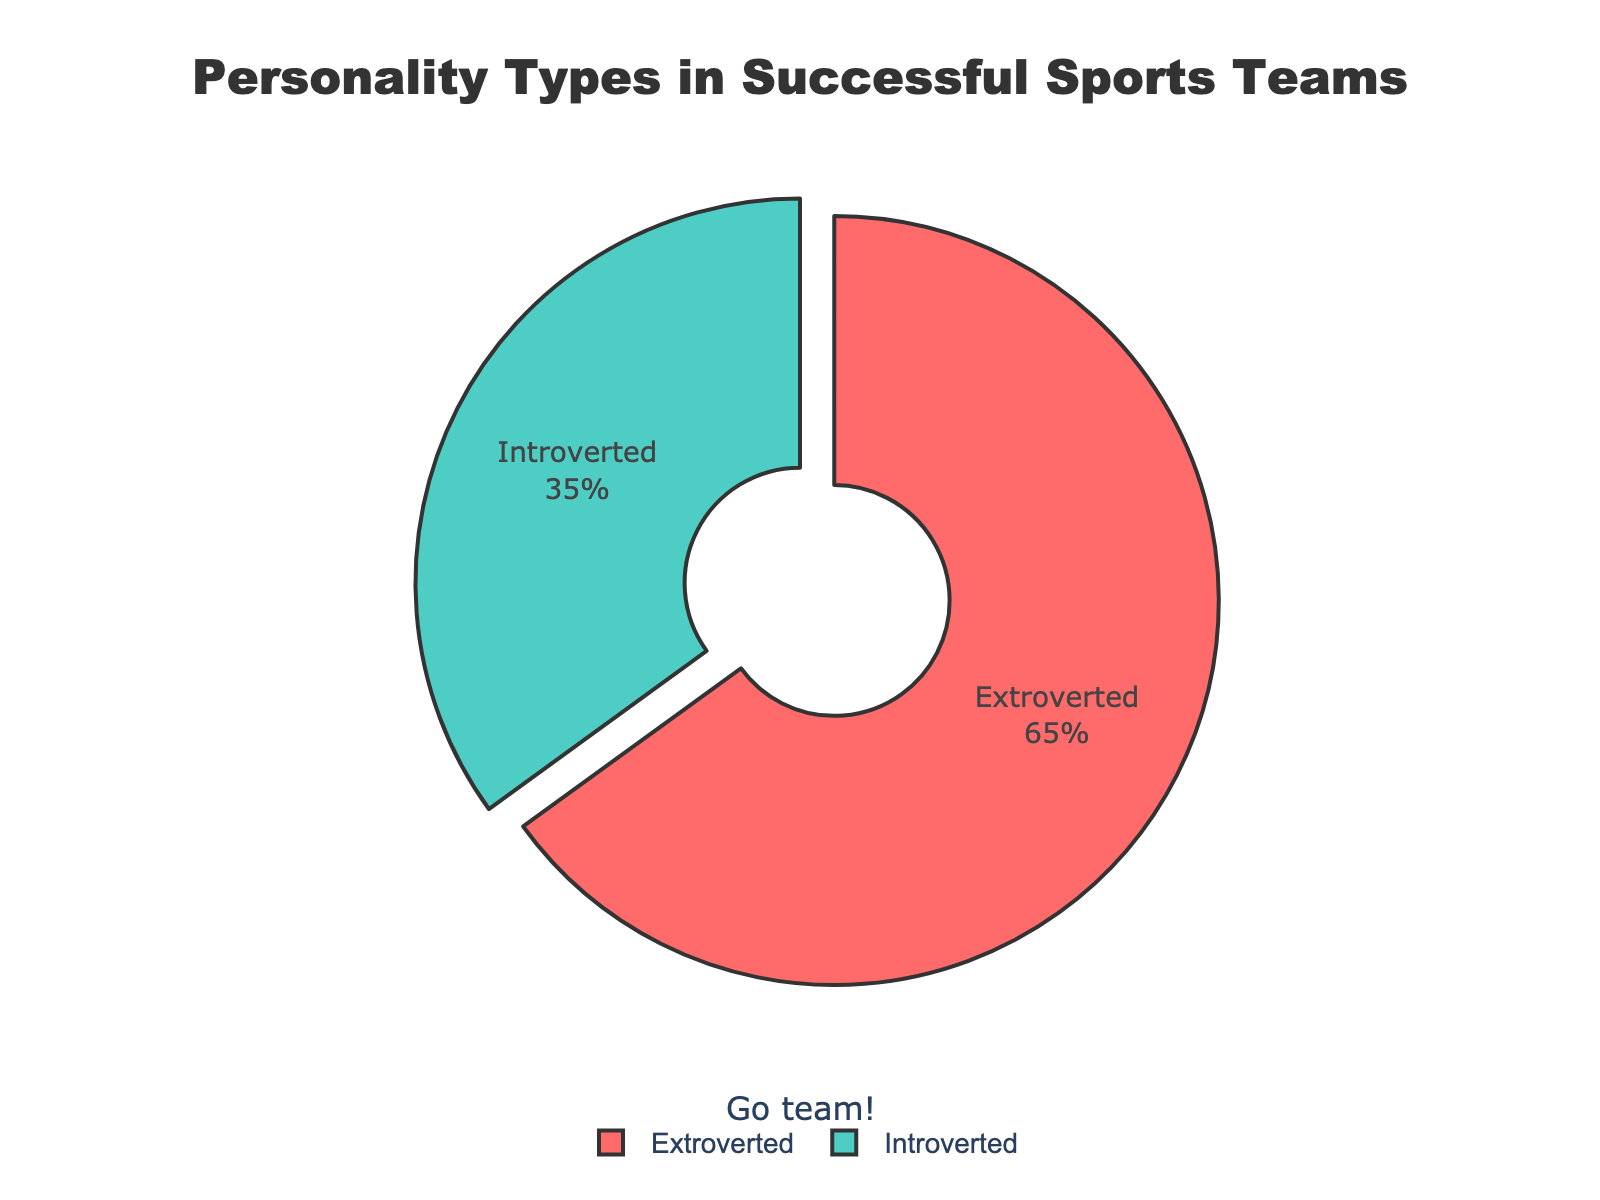What percentage of personalities in successful sports teams are extroverted? The figure shows a pie chart where the percentage of extroverted personalities is directly labeled.
Answer: 65% What percentage of personalities in successful sports teams are introverted? The figure shows a pie chart where the percentage of introverted personalities is directly labeled.
Answer: 35% Is the percentage of extroverted personalities greater than the percentage of introverted personalities in successful sports teams? By comparing the percentages from the chart, we see that the percentage of extroverted (65%) is greater than that of introverted (35%).
Answer: Yes What is the difference in percentage between extroverted and introverted personalities in successful sports teams? Subtract the percentage of introverted personalities from the percentage of extroverted personalities: 65% - 35%.
Answer: 30% Which color represents the extroverted personalities in the pie chart? The figure uses a noticeable color scheme where extroverted personalities are labeled with their color: red.
Answer: Red Which personality type is represented by the teal color in the pie chart? The figure shows that introverted personalities are labeled with the teal color.
Answer: Introverted Which personality type has the larger share in the pie chart? The figure shows the larger segment of the pie chart with 65%, which represents extroverted personalities.
Answer: Extroverted Calculate the total percentage represented in the pie chart. Add the percentages represented by extroverted and introverted personalities: 65% + 35%.
Answer: 100% What is the ratio of extroverted to introverted personalities in successful sports teams? The ratio is determined by dividing the percentage of extroverted personalities by the percentage of introverted personalities: 65 / 35.
Answer: 65:35 or approximately 1.86:1 How much is the pull effect applied to the extroverted segment of the pie chart? The figure shows the extroverted segment is slightly separated from the pie chart, indicating the pull effect is applied. This effect is specifically mentioned as 0.1 in the principles of pull effect.
Answer: 0.1 